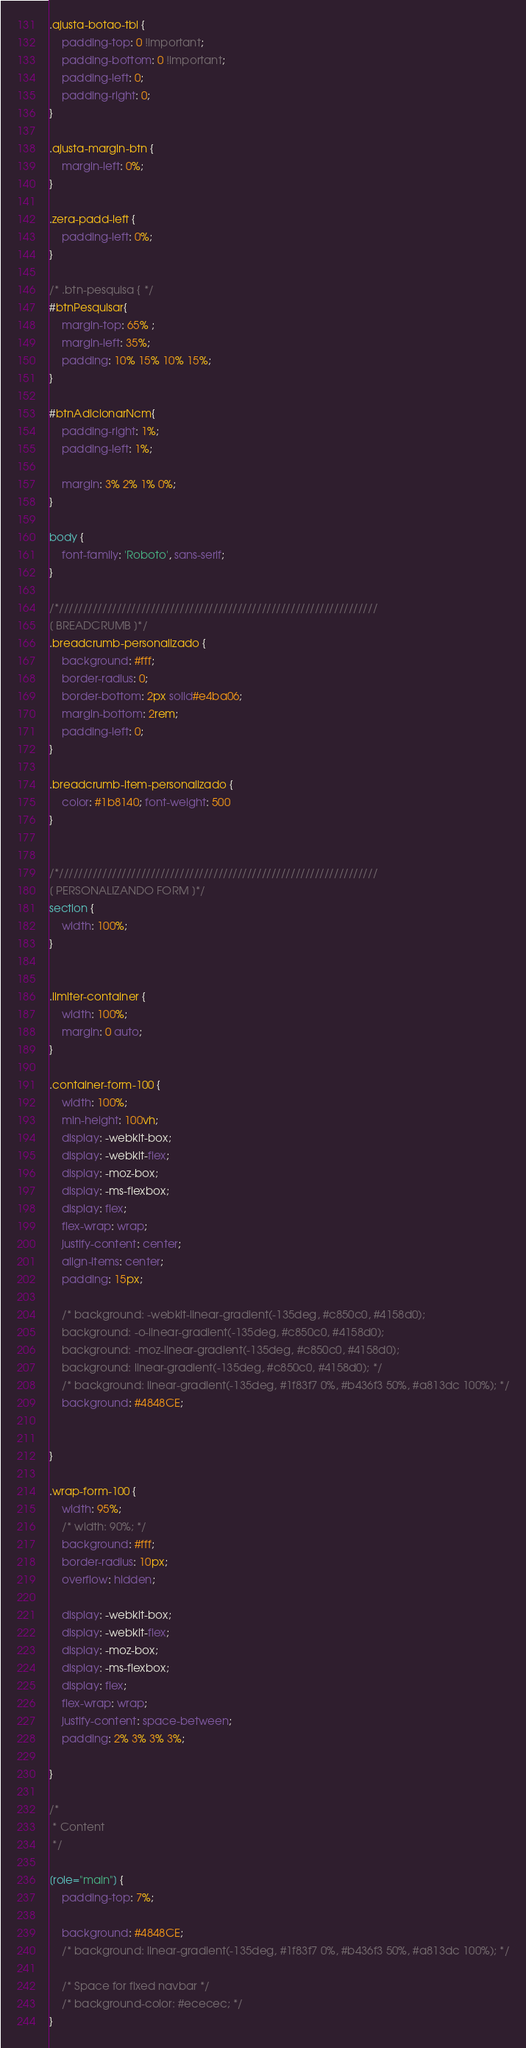Convert code to text. <code><loc_0><loc_0><loc_500><loc_500><_CSS_>.ajusta-botao-tbl {
    padding-top: 0 !important;
    padding-bottom: 0 !important;
    padding-left: 0;
    padding-right: 0;
}

.ajusta-margin-btn {
    margin-left: 0%;
}

.zera-padd-left {
    padding-left: 0%;
}

/* .btn-pesquisa { */
#btnPesquisar{    
    margin-top: 65% ;
    margin-left: 35%;    
    padding: 10% 15% 10% 15%;
}

#btnAdicionarNcm{
    padding-right: 1%;
    padding-left: 1%;

    margin: 3% 2% 1% 0%;
}

body {
    font-family: 'Roboto', sans-serif;
}

/*//////////////////////////////////////////////////////////////////
[ BREADCRUMB ]*/
.breadcrumb-personalizado {
    background: #fff; 
    border-radius: 0;
    border-bottom: 2px solid#e4ba06;
    margin-bottom: 2rem;
    padding-left: 0;
}

.breadcrumb-item-personalizado {
    color: #1b8140; font-weight: 500
}


/*//////////////////////////////////////////////////////////////////
[ PERSONALIZANDO FORM ]*/
section {
    width: 100%;
}


.limiter-container {
    width: 100%;
    margin: 0 auto;
}
  
.container-form-100 {
    width: 100%;  
    min-height: 100vh;
    display: -webkit-box;
    display: -webkit-flex;
    display: -moz-box;
    display: -ms-flexbox;
    display: flex;
    flex-wrap: wrap;
    justify-content: center;
    align-items: center;
    padding: 15px;
  
    /* background: -webkit-linear-gradient(-135deg, #c850c0, #4158d0);
    background: -o-linear-gradient(-135deg, #c850c0, #4158d0);
    background: -moz-linear-gradient(-135deg, #c850c0, #4158d0);
    background: linear-gradient(-135deg, #c850c0, #4158d0); */
    /* background: linear-gradient(-135deg, #1f83f7 0%, #b436f3 50%, #a813dc 100%); */
    background: #4848CE;


}

.wrap-form-100 {
    width: 95%;
    /* width: 90%; */
    background: #fff;
    border-radius: 10px;
    overflow: hidden;
  
    display: -webkit-box;
    display: -webkit-flex;
    display: -moz-box;
    display: -ms-flexbox;
    display: flex;
    flex-wrap: wrap;
    justify-content: space-between;
    padding: 2% 3% 3% 3%;

}
  
/*
 * Content
 */

[role="main"] {
    padding-top: 7%;

    background: #4848CE;
    /* background: linear-gradient(-135deg, #1f83f7 0%, #b436f3 50%, #a813dc 100%); */

    /* Space for fixed navbar */
    /* background-color: #ececec; */
}
</code> 